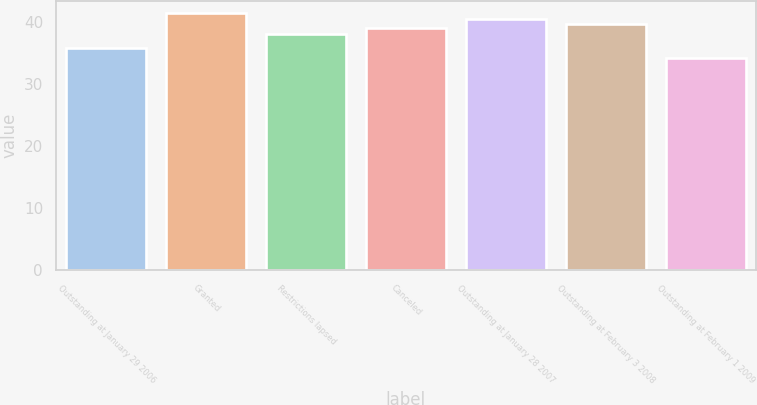Convert chart. <chart><loc_0><loc_0><loc_500><loc_500><bar_chart><fcel>Outstanding at January 29 2006<fcel>Granted<fcel>Restrictions lapsed<fcel>Canceled<fcel>Outstanding at January 28 2007<fcel>Outstanding at February 3 2008<fcel>Outstanding at February 1 2009<nl><fcel>35.76<fcel>41.37<fcel>38.03<fcel>39<fcel>40.44<fcel>39.72<fcel>34.22<nl></chart> 